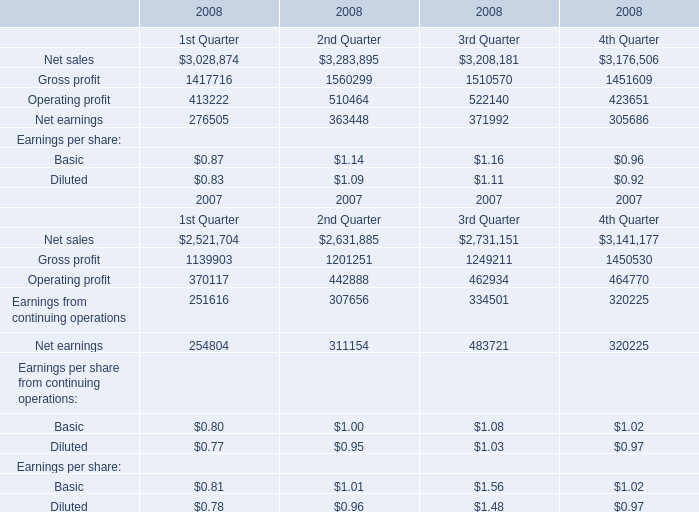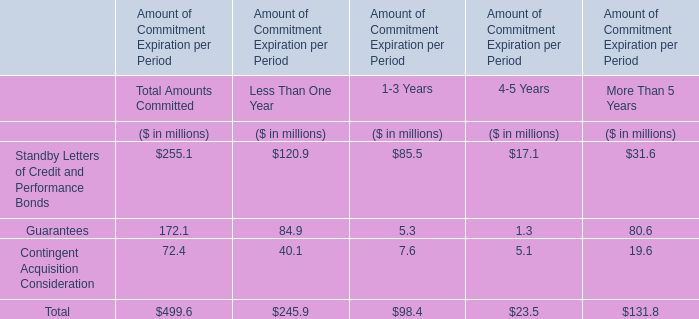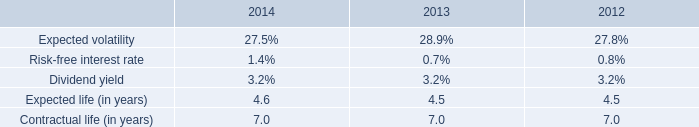What was the total amount of the Gross profit in the years where Net earnings is greater than 480000? 
Computations: (((1139903 + 1201251) + 1249211) + 1450530)
Answer: 5040895.0. 